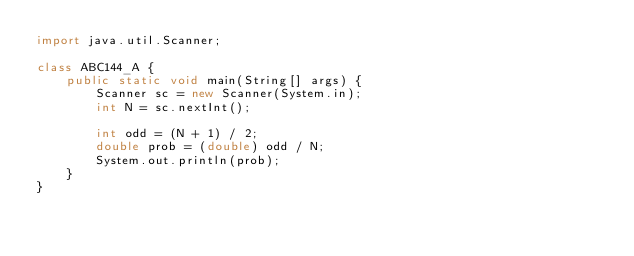Convert code to text. <code><loc_0><loc_0><loc_500><loc_500><_Java_>import java.util.Scanner;

class ABC144_A {
    public static void main(String[] args) {
        Scanner sc = new Scanner(System.in);
        int N = sc.nextInt();

        int odd = (N + 1) / 2;
        double prob = (double) odd / N;
        System.out.println(prob);
    }
}</code> 